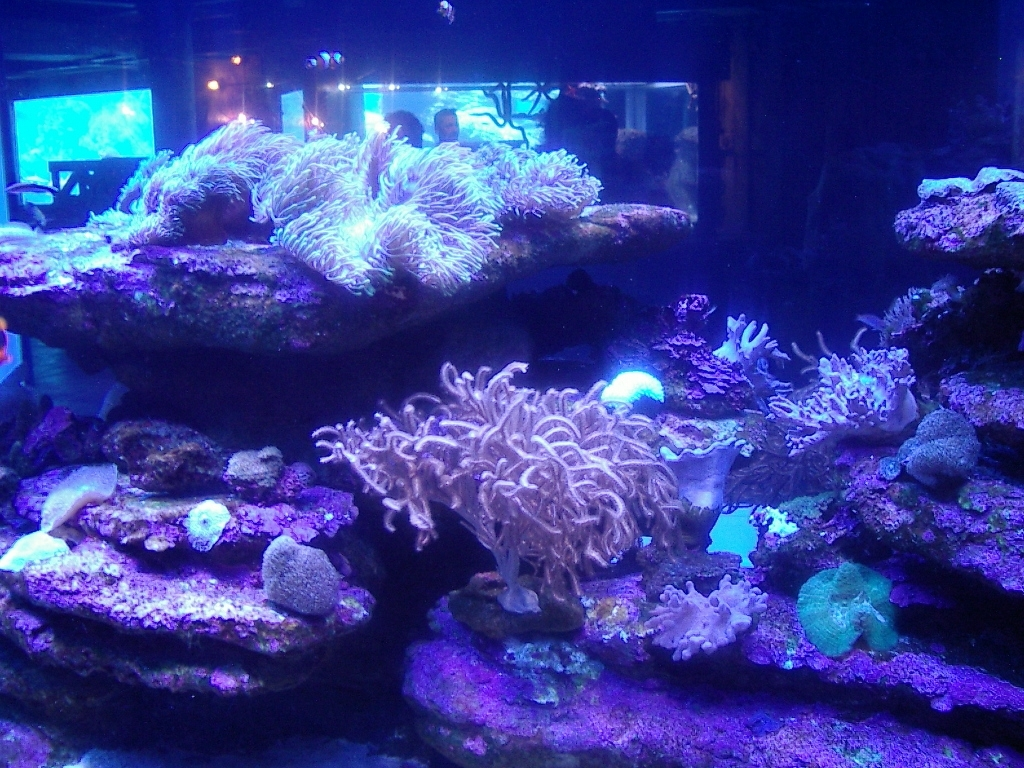What kind of species might live in this habitat, and are any visible in the image? In such artificial reef environments, you would typically find a variety of coral species, reef fish, crustaceans, and other invertebrates. In this image, there are several types of corals visible, including what appear to be soft corals and stony corals, but there are no fish or mobile invertebrates easily discernible. 